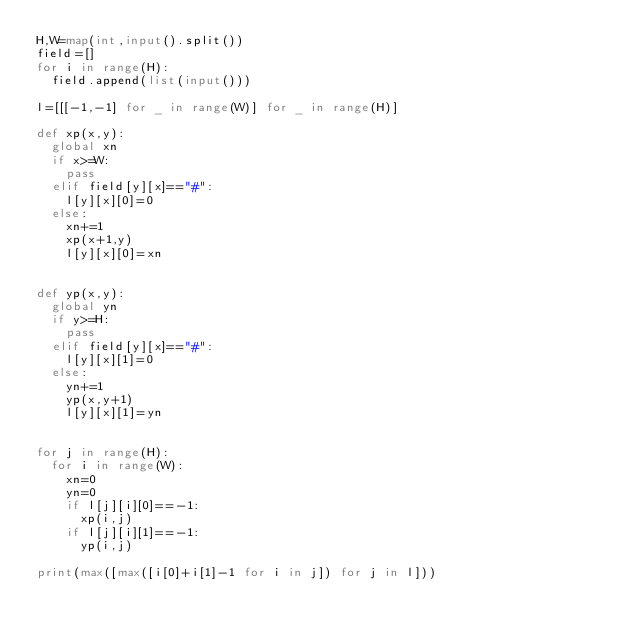Convert code to text. <code><loc_0><loc_0><loc_500><loc_500><_Python_>H,W=map(int,input().split())
field=[]
for i in range(H):
  field.append(list(input()))

l=[[[-1,-1] for _ in range(W)] for _ in range(H)]

def xp(x,y):
  global xn
  if x>=W:
    pass
  elif field[y][x]=="#":
    l[y][x][0]=0
  else:
    xn+=1
    xp(x+1,y)
    l[y][x][0]=xn


def yp(x,y):
  global yn
  if y>=H:
    pass
  elif field[y][x]=="#":
    l[y][x][1]=0
  else:
    yn+=1
    yp(x,y+1)
    l[y][x][1]=yn


for j in range(H):
  for i in range(W):
    xn=0
    yn=0
    if l[j][i][0]==-1:
      xp(i,j)
    if l[j][i][1]==-1:
      yp(i,j)

print(max([max([i[0]+i[1]-1 for i in j]) for j in l]))</code> 